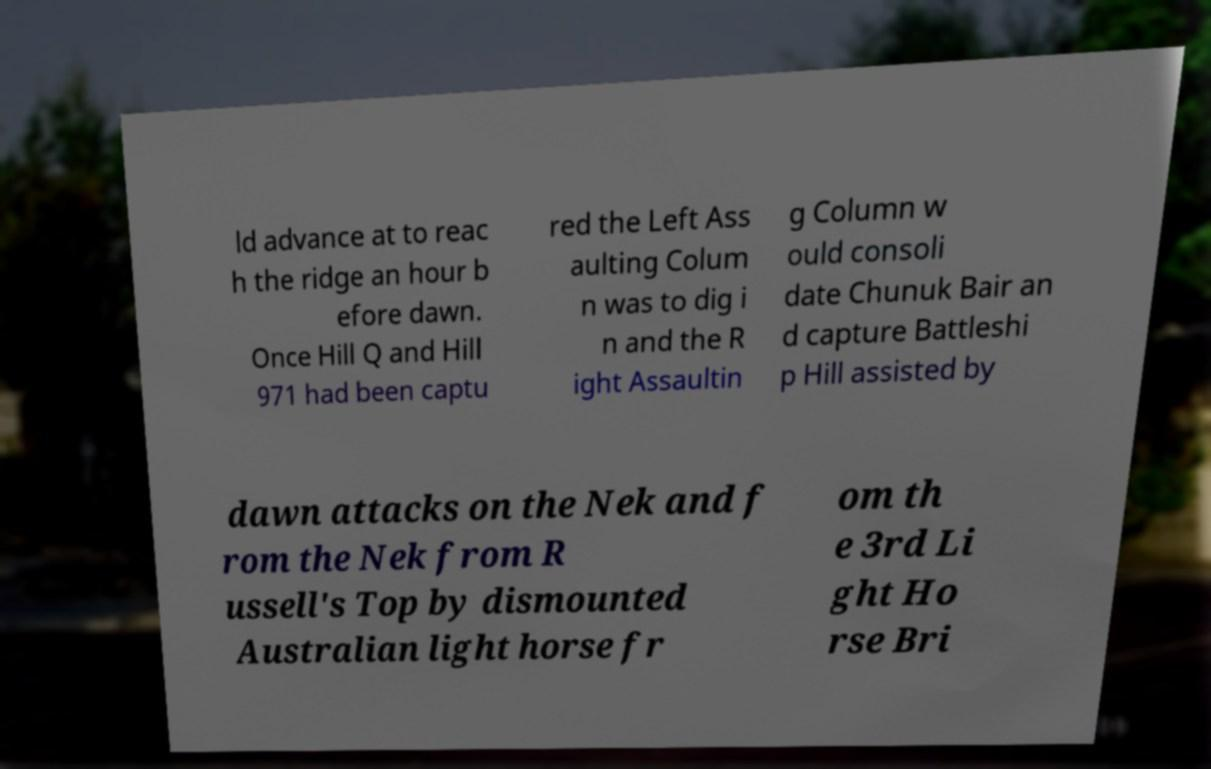Please read and relay the text visible in this image. What does it say? ld advance at to reac h the ridge an hour b efore dawn. Once Hill Q and Hill 971 had been captu red the Left Ass aulting Colum n was to dig i n and the R ight Assaultin g Column w ould consoli date Chunuk Bair an d capture Battleshi p Hill assisted by dawn attacks on the Nek and f rom the Nek from R ussell's Top by dismounted Australian light horse fr om th e 3rd Li ght Ho rse Bri 